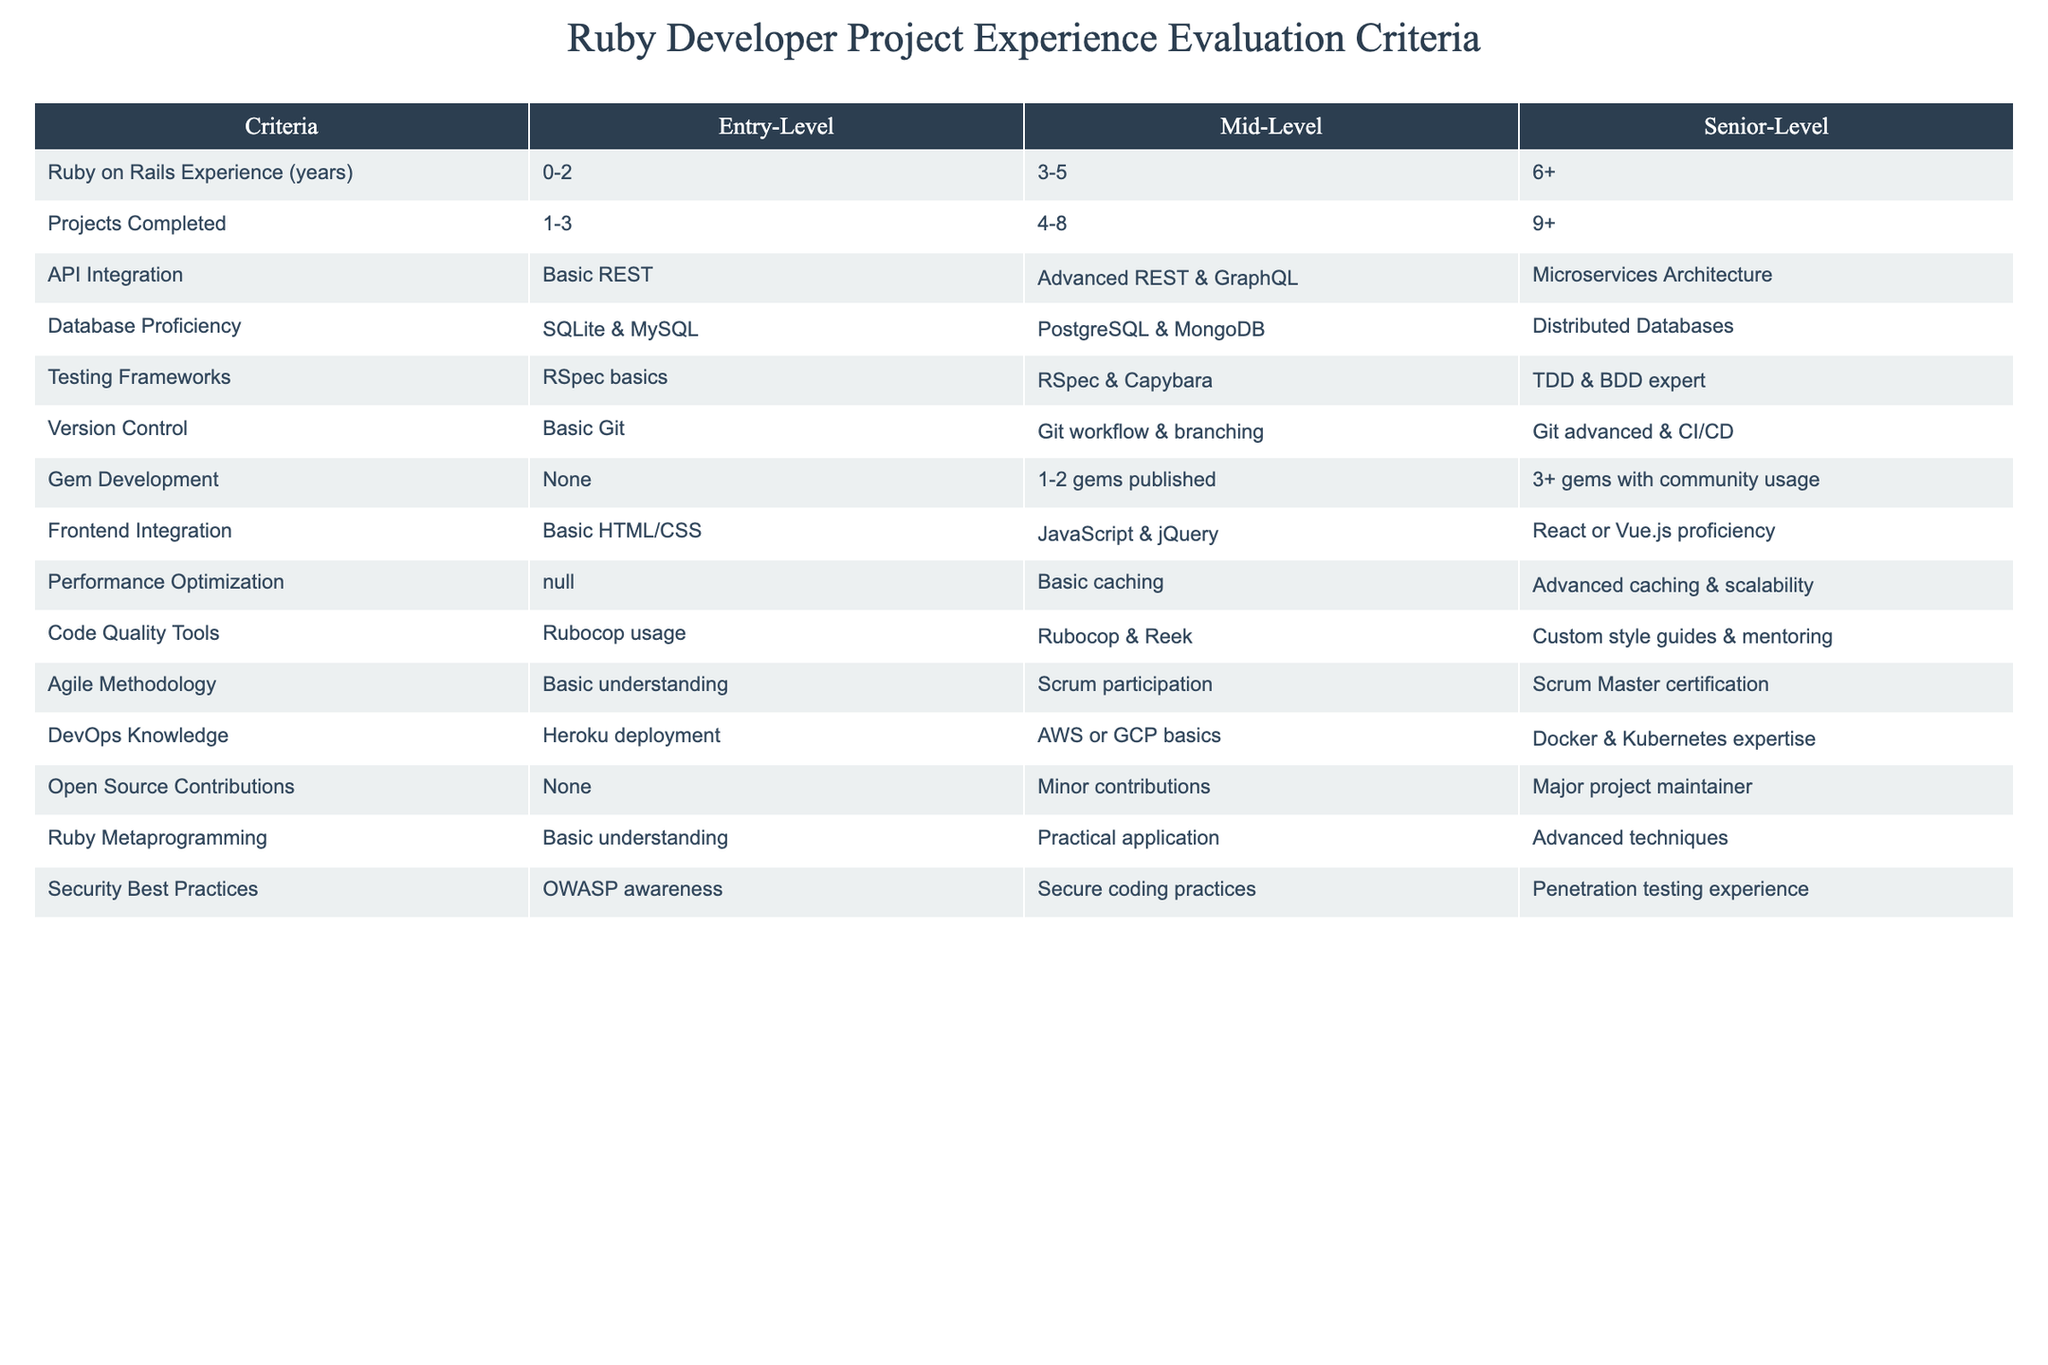What is the required Ruby on Rails experience for a Senior-Level developer? According to the table, a Senior-Level developer needs 6 or more years of Ruby on Rails experience.
Answer: 6+ How many projects should an Entry-Level Ruby developer ideally have completed? The table indicates that an Entry-Level developer should have completed between 1 to 3 projects.
Answer: 1-3 Is API integration for Senior-Level developers focused on Microservices Architecture? Yes, the table confirms that the criteria for Senior-Level developers includes Microservices Architecture in API Integration.
Answer: True How many gems must a Senior-Level developer have published? Senior-Level developers need to have published 3 or more gems used by the community, as per the table.
Answer: 3+ What is the difference in testing framework requirements between Mid-Level and Senior-Level developers? The Mid-Level developers are described as RSpec and Capybara users, while Senior-Level developers are experts in TDD and BDD, indicating a more advanced level of skill and practices in testing frameworks.
Answer: TDD and BDD expertise How many years of database proficiency in PostgreSQL and MongoDB are required for Mid-Level developers? Mid-Level developers are required to have proficiency in PostgreSQL and MongoDB specifically within a range of 3 to 5 years, as defined in the table.
Answer: 3-5 years Do Entry-Level Ruby developers need knowledge in Agile Methodology? Yes, the table shows that Entry-Level developers need at least a basic understanding of Agile Methodology.
Answer: True Which level of developers is expected to have a custom style guide and mentoring experience regarding code quality tools? The table specifies that such expectations fall under Senior-Level developers, requiring them to have custom style guides and mentoring experience.
Answer: Senior-Level How many major open source contributions are required for a Senior-Level role? The criteria for a Senior-Level developer indicates they should be a major project maintainer concerning open source contributions.
Answer: Major project maintainer What can be inferred about the DevOps knowledge requirement for Mid-Level and Senior-Level developers? The table indicates Mid-Level developers should have basic knowledge of AWS or GCP, while Senior-Level developers require expertise in Docker and Kubernetes, implying a progression in DevOps knowledge expectations.
Answer: Progression from basic to advanced knowledge 